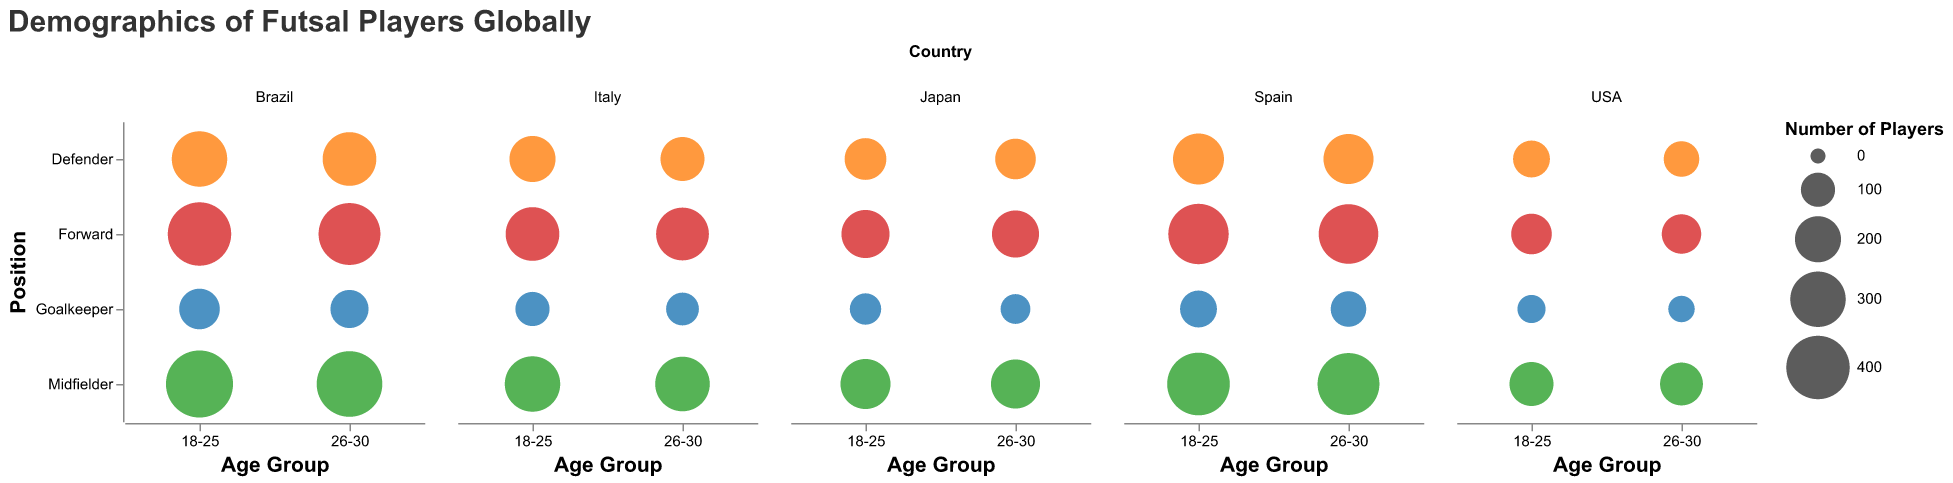How many goalkeepers in the 18-25 age group are from Brazil? Locate the "Brazil" subplot and find the bubble at the intersection of "18-25" on the x-axis and "Goalkeeper" on the y-axis. The tooltip or the bubble size should indicate 150 players.
Answer: 150 Which country has the smallest number of forwards in the 26-30 age group? Compare the bubble sizes for the "Forward" position in the "26-30" age group across all subplots. The smallest bubble for forwards in this age group appears in the USA subplot, containing 140 players.
Answer: USA What is the total number of midfielders in Spain across all age groups? Sum the number of midfielders in Spain for both age groups: 390 in the 18-25 group and 380 in the 26-30 group. Therefore, the total is 390 + 380 = 770.
Answer: 770 Which position has the most players in the 18-25 age group across all countries? Add the number of players in each position in the 18-25 age group across all countries:
- Goalkeeper: 150 (Brazil) + 120 (Spain) + 100 (Italy) + 80 (Japan) + 60 (USA) = 510.
- Defender: 300 (Brazil) + 250 (Spain) + 200 (Italy) + 160 (Japan) + 120 (USA) = 1030.
- Midfielder: 450 (Brazil) + 390 (Spain) + 300 (Italy) + 240 (Japan) + 180 (USA) = 1560.
- Forward: 400 (Brazil) + 360 (Spain) + 280 (Italy) + 220 (Japan) + 150 (USA) = 1410.
The position with the most players is Midfielder with 1560 players.
Answer: Midfielder Which country has the most balanced number of players across all positions and age groups? Check and compare the bubble sizes across each subplot. Japan shows relatively balanced bubble sizes across both age groups and all positions, indicating a more even distribution.
Answer: Japan How many total players are there in the 26-30 age group for Italy? Add the number of players in Italy for the 26-30 age group across all positions: 90 (Goalkeeper) + 180 (Defender) + 290 (Midfielder) + 270 (Forward) = 830.
Answer: 830 Compare the number of defenders in the 26-30 age group between Brazil and Spain. Which country has more defenders? Find the bubbles representing defenders in the 26-30 age group in Brazil and Spain:
- Brazil has 280 defenders.
- Spain has 240 defenders.
Brazil has more defenders in this age group.
Answer: Brazil What is the overall number of futsal players in the USA across all positions and age groups? Sum the number of players in the USA for both age groups and all positions: 60 (Goalkeeper, 18-25) + 120 (Defender, 18-25) + 180 (Midfielder, 18-25) + 150 (Forward, 18-25) + 50 (Goalkeeper, 26-30) + 110 (Defender, 26-30) + 170 (Midfielder, 26-30) + 140 (Forward, 26-30) = 980.
Answer: 980 